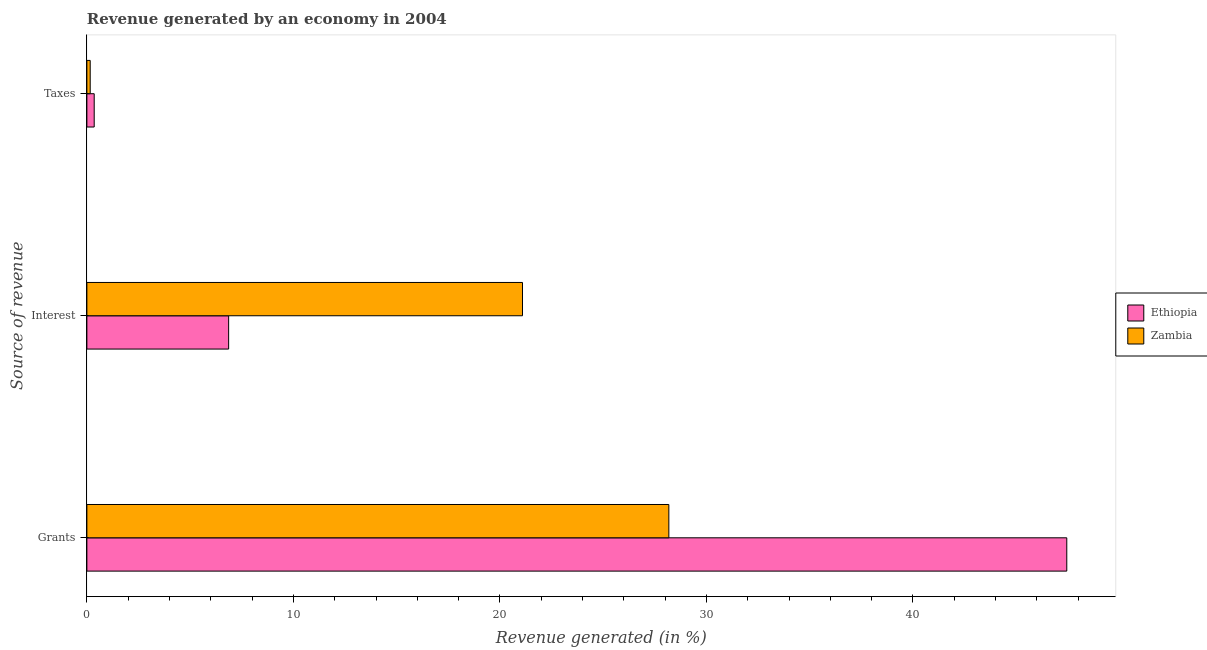Are the number of bars on each tick of the Y-axis equal?
Provide a short and direct response. Yes. What is the label of the 2nd group of bars from the top?
Make the answer very short. Interest. What is the percentage of revenue generated by interest in Ethiopia?
Your answer should be very brief. 6.86. Across all countries, what is the maximum percentage of revenue generated by taxes?
Your response must be concise. 0.35. Across all countries, what is the minimum percentage of revenue generated by taxes?
Provide a short and direct response. 0.16. In which country was the percentage of revenue generated by taxes maximum?
Your answer should be very brief. Ethiopia. In which country was the percentage of revenue generated by interest minimum?
Make the answer very short. Ethiopia. What is the total percentage of revenue generated by taxes in the graph?
Your answer should be very brief. 0.52. What is the difference between the percentage of revenue generated by taxes in Zambia and that in Ethiopia?
Give a very brief answer. -0.19. What is the difference between the percentage of revenue generated by interest in Ethiopia and the percentage of revenue generated by grants in Zambia?
Your response must be concise. -21.31. What is the average percentage of revenue generated by interest per country?
Your answer should be very brief. 13.98. What is the difference between the percentage of revenue generated by interest and percentage of revenue generated by grants in Zambia?
Your answer should be compact. -7.09. In how many countries, is the percentage of revenue generated by taxes greater than 8 %?
Your answer should be very brief. 0. What is the ratio of the percentage of revenue generated by interest in Zambia to that in Ethiopia?
Offer a terse response. 3.07. Is the percentage of revenue generated by taxes in Ethiopia less than that in Zambia?
Your answer should be compact. No. Is the difference between the percentage of revenue generated by grants in Ethiopia and Zambia greater than the difference between the percentage of revenue generated by interest in Ethiopia and Zambia?
Your answer should be compact. Yes. What is the difference between the highest and the second highest percentage of revenue generated by interest?
Make the answer very short. 14.23. What is the difference between the highest and the lowest percentage of revenue generated by interest?
Your response must be concise. 14.23. Is the sum of the percentage of revenue generated by grants in Zambia and Ethiopia greater than the maximum percentage of revenue generated by interest across all countries?
Your answer should be very brief. Yes. What does the 2nd bar from the top in Interest represents?
Your response must be concise. Ethiopia. What does the 2nd bar from the bottom in Taxes represents?
Ensure brevity in your answer.  Zambia. Is it the case that in every country, the sum of the percentage of revenue generated by grants and percentage of revenue generated by interest is greater than the percentage of revenue generated by taxes?
Your answer should be very brief. Yes. How many bars are there?
Keep it short and to the point. 6. How many countries are there in the graph?
Provide a succinct answer. 2. How many legend labels are there?
Offer a very short reply. 2. What is the title of the graph?
Offer a terse response. Revenue generated by an economy in 2004. What is the label or title of the X-axis?
Keep it short and to the point. Revenue generated (in %). What is the label or title of the Y-axis?
Offer a terse response. Source of revenue. What is the Revenue generated (in %) in Ethiopia in Grants?
Your response must be concise. 47.45. What is the Revenue generated (in %) of Zambia in Grants?
Your response must be concise. 28.18. What is the Revenue generated (in %) of Ethiopia in Interest?
Ensure brevity in your answer.  6.86. What is the Revenue generated (in %) of Zambia in Interest?
Make the answer very short. 21.09. What is the Revenue generated (in %) of Ethiopia in Taxes?
Make the answer very short. 0.35. What is the Revenue generated (in %) of Zambia in Taxes?
Your answer should be compact. 0.16. Across all Source of revenue, what is the maximum Revenue generated (in %) in Ethiopia?
Keep it short and to the point. 47.45. Across all Source of revenue, what is the maximum Revenue generated (in %) in Zambia?
Ensure brevity in your answer.  28.18. Across all Source of revenue, what is the minimum Revenue generated (in %) in Ethiopia?
Provide a short and direct response. 0.35. Across all Source of revenue, what is the minimum Revenue generated (in %) in Zambia?
Provide a succinct answer. 0.16. What is the total Revenue generated (in %) in Ethiopia in the graph?
Ensure brevity in your answer.  54.67. What is the total Revenue generated (in %) of Zambia in the graph?
Your response must be concise. 49.43. What is the difference between the Revenue generated (in %) of Ethiopia in Grants and that in Interest?
Provide a short and direct response. 40.58. What is the difference between the Revenue generated (in %) of Zambia in Grants and that in Interest?
Ensure brevity in your answer.  7.09. What is the difference between the Revenue generated (in %) of Ethiopia in Grants and that in Taxes?
Make the answer very short. 47.09. What is the difference between the Revenue generated (in %) in Zambia in Grants and that in Taxes?
Your answer should be compact. 28.02. What is the difference between the Revenue generated (in %) in Ethiopia in Interest and that in Taxes?
Make the answer very short. 6.51. What is the difference between the Revenue generated (in %) of Zambia in Interest and that in Taxes?
Your response must be concise. 20.93. What is the difference between the Revenue generated (in %) of Ethiopia in Grants and the Revenue generated (in %) of Zambia in Interest?
Provide a succinct answer. 26.36. What is the difference between the Revenue generated (in %) in Ethiopia in Grants and the Revenue generated (in %) in Zambia in Taxes?
Provide a succinct answer. 47.29. What is the difference between the Revenue generated (in %) in Ethiopia in Interest and the Revenue generated (in %) in Zambia in Taxes?
Your answer should be very brief. 6.7. What is the average Revenue generated (in %) in Ethiopia per Source of revenue?
Ensure brevity in your answer.  18.22. What is the average Revenue generated (in %) in Zambia per Source of revenue?
Give a very brief answer. 16.48. What is the difference between the Revenue generated (in %) in Ethiopia and Revenue generated (in %) in Zambia in Grants?
Your response must be concise. 19.27. What is the difference between the Revenue generated (in %) of Ethiopia and Revenue generated (in %) of Zambia in Interest?
Provide a succinct answer. -14.23. What is the difference between the Revenue generated (in %) of Ethiopia and Revenue generated (in %) of Zambia in Taxes?
Keep it short and to the point. 0.19. What is the ratio of the Revenue generated (in %) of Ethiopia in Grants to that in Interest?
Offer a very short reply. 6.91. What is the ratio of the Revenue generated (in %) of Zambia in Grants to that in Interest?
Your answer should be very brief. 1.34. What is the ratio of the Revenue generated (in %) in Ethiopia in Grants to that in Taxes?
Make the answer very short. 133.67. What is the ratio of the Revenue generated (in %) in Zambia in Grants to that in Taxes?
Give a very brief answer. 174.9. What is the ratio of the Revenue generated (in %) of Ethiopia in Interest to that in Taxes?
Keep it short and to the point. 19.34. What is the ratio of the Revenue generated (in %) of Zambia in Interest to that in Taxes?
Your response must be concise. 130.92. What is the difference between the highest and the second highest Revenue generated (in %) of Ethiopia?
Make the answer very short. 40.58. What is the difference between the highest and the second highest Revenue generated (in %) in Zambia?
Keep it short and to the point. 7.09. What is the difference between the highest and the lowest Revenue generated (in %) in Ethiopia?
Ensure brevity in your answer.  47.09. What is the difference between the highest and the lowest Revenue generated (in %) of Zambia?
Your answer should be very brief. 28.02. 